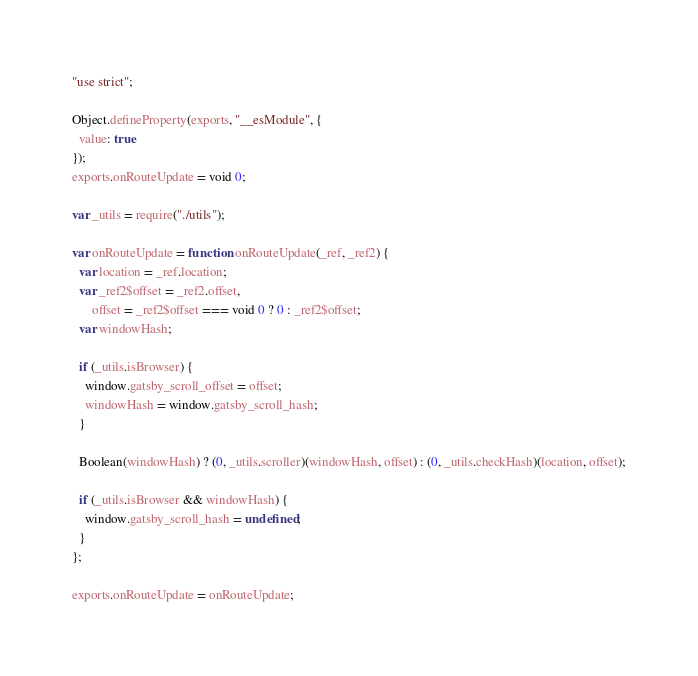<code> <loc_0><loc_0><loc_500><loc_500><_JavaScript_>"use strict";

Object.defineProperty(exports, "__esModule", {
  value: true
});
exports.onRouteUpdate = void 0;

var _utils = require("./utils");

var onRouteUpdate = function onRouteUpdate(_ref, _ref2) {
  var location = _ref.location;
  var _ref2$offset = _ref2.offset,
      offset = _ref2$offset === void 0 ? 0 : _ref2$offset;
  var windowHash;

  if (_utils.isBrowser) {
    window.gatsby_scroll_offset = offset;
    windowHash = window.gatsby_scroll_hash;
  }

  Boolean(windowHash) ? (0, _utils.scroller)(windowHash, offset) : (0, _utils.checkHash)(location, offset);

  if (_utils.isBrowser && windowHash) {
    window.gatsby_scroll_hash = undefined;
  }
};

exports.onRouteUpdate = onRouteUpdate;</code> 